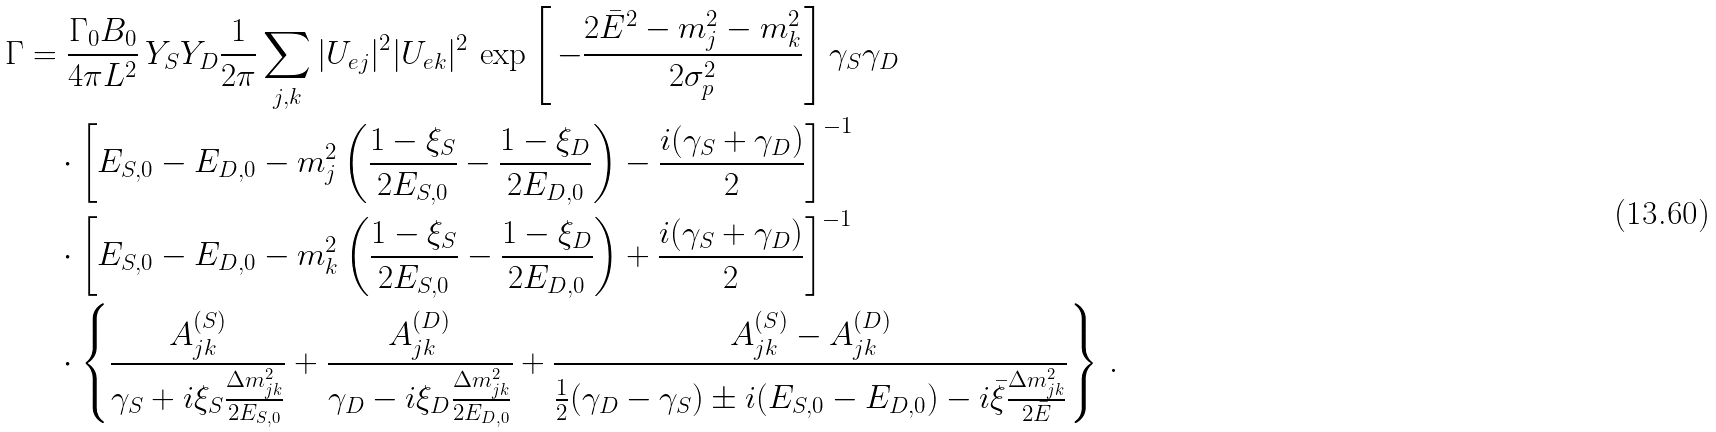<formula> <loc_0><loc_0><loc_500><loc_500>\Gamma & = \frac { \Gamma _ { 0 } B _ { 0 } } { 4 \pi L ^ { 2 } } \, Y _ { S } Y _ { D } \frac { 1 } { 2 \pi } \sum _ { j , k } | U _ { e j } | ^ { 2 } | U _ { e k } | ^ { 2 } \, \exp \left [ \, - \frac { 2 \bar { E } ^ { 2 } - m _ { j } ^ { 2 } - m _ { k } ^ { 2 } } { 2 \sigma _ { p } ^ { 2 } } \right ] \gamma _ { S } \gamma _ { D } \\ & \quad \cdot \left [ E _ { S , 0 } - E _ { D , 0 } - m _ { j } ^ { 2 } \left ( \frac { 1 - \xi _ { S } } { 2 E _ { S , 0 } } - \frac { 1 - \xi _ { D } } { 2 E _ { D , 0 } } \right ) - \frac { i ( \gamma _ { S } + \gamma _ { D } ) } { 2 } \right ] ^ { - 1 } \\ & \quad \cdot \left [ E _ { S , 0 } - E _ { D , 0 } - m _ { k } ^ { 2 } \left ( \frac { 1 - \xi _ { S } } { 2 E _ { S , 0 } } - \frac { 1 - \xi _ { D } } { 2 E _ { D , 0 } } \right ) + \frac { i ( \gamma _ { S } + \gamma _ { D } ) } { 2 } \right ] ^ { - 1 } \\ & \quad \cdot \left \{ \frac { A ^ { ( S ) } _ { j k } } { \gamma _ { S } + i \xi _ { S } \frac { \Delta m _ { j k } ^ { 2 } } { 2 E _ { S , 0 } } } + \frac { A ^ { ( D ) } _ { j k } } { \gamma _ { D } - i \xi _ { D } \frac { \Delta m _ { j k } ^ { 2 } } { 2 E _ { D , 0 } } } + \frac { A ^ { ( S ) } _ { j k } - A ^ { ( D ) } _ { j k } } { \frac { 1 } { 2 } ( \gamma _ { D } - \gamma _ { S } ) \pm i ( E _ { S , 0 } - E _ { D , 0 } ) - i \bar { \xi } \frac { \Delta m _ { j k } ^ { 2 } } { 2 \bar { E } } } \right \} \, .</formula> 